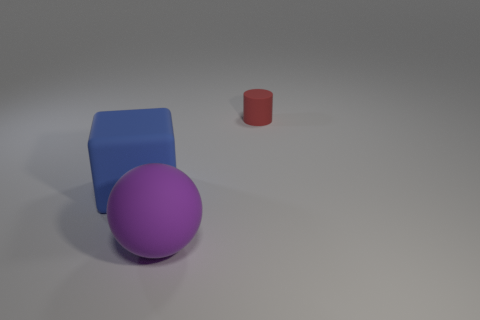Add 3 small blue matte things. How many objects exist? 6 Subtract all blocks. How many objects are left? 2 Add 1 large blue blocks. How many large blue blocks are left? 2 Add 1 purple things. How many purple things exist? 2 Subtract 0 brown balls. How many objects are left? 3 Subtract all purple rubber cubes. Subtract all red matte cylinders. How many objects are left? 2 